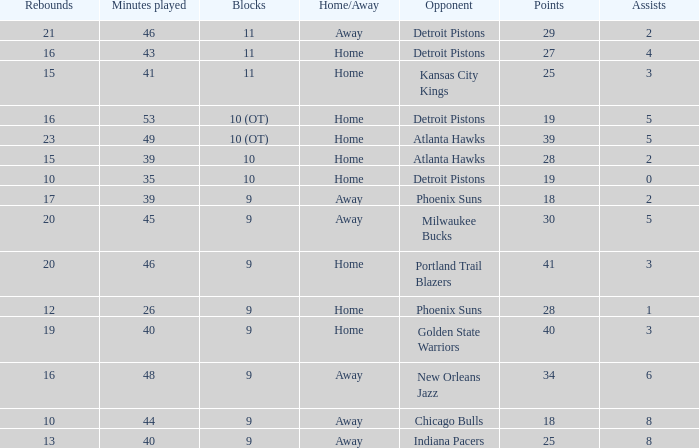How many minutes were played when there were 18 points and the opponent was Chicago Bulls? 1.0. Would you be able to parse every entry in this table? {'header': ['Rebounds', 'Minutes played', 'Blocks', 'Home/Away', 'Opponent', 'Points', 'Assists'], 'rows': [['21', '46', '11', 'Away', 'Detroit Pistons', '29', '2'], ['16', '43', '11', 'Home', 'Detroit Pistons', '27', '4'], ['15', '41', '11', 'Home', 'Kansas City Kings', '25', '3'], ['16', '53', '10 (OT)', 'Home', 'Detroit Pistons', '19', '5'], ['23', '49', '10 (OT)', 'Home', 'Atlanta Hawks', '39', '5'], ['15', '39', '10', 'Home', 'Atlanta Hawks', '28', '2'], ['10', '35', '10', 'Home', 'Detroit Pistons', '19', '0'], ['17', '39', '9', 'Away', 'Phoenix Suns', '18', '2'], ['20', '45', '9', 'Away', 'Milwaukee Bucks', '30', '5'], ['20', '46', '9', 'Home', 'Portland Trail Blazers', '41', '3'], ['12', '26', '9', 'Home', 'Phoenix Suns', '28', '1'], ['19', '40', '9', 'Home', 'Golden State Warriors', '40', '3'], ['16', '48', '9', 'Away', 'New Orleans Jazz', '34', '6'], ['10', '44', '9', 'Away', 'Chicago Bulls', '18', '8'], ['13', '40', '9', 'Away', 'Indiana Pacers', '25', '8']]} 